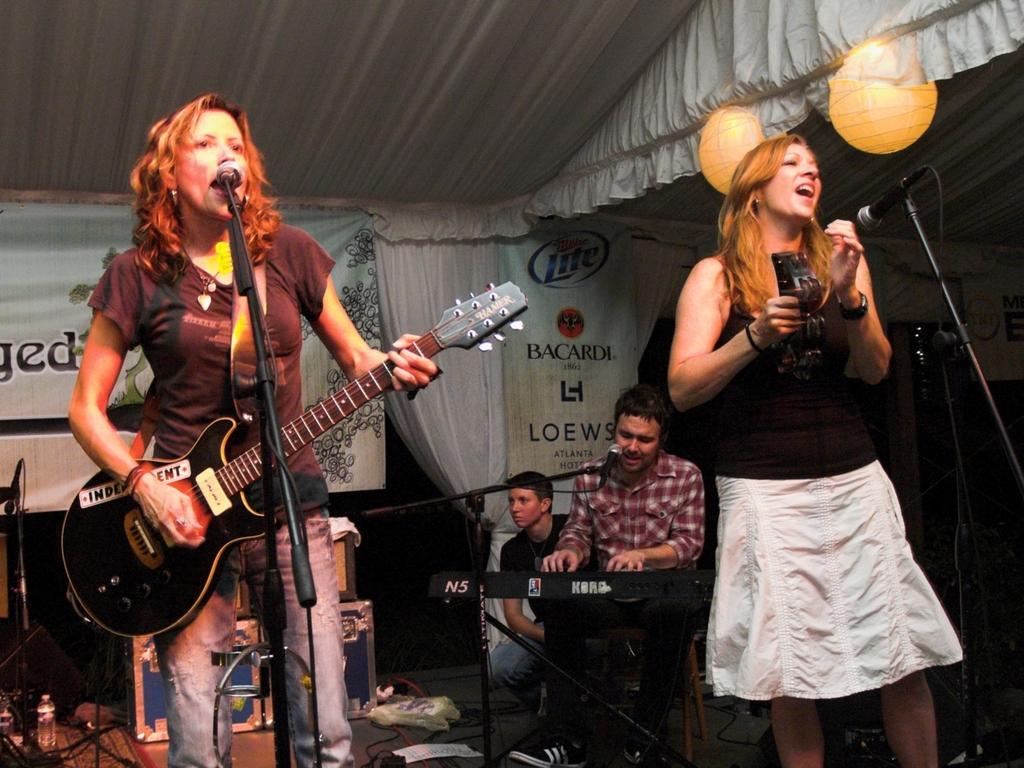Please provide a concise description of this image. These 2 women are playing musical instrument and singing in-front of mic. This man is sitting and playing a piano and singing in-front of mic. A banner on curtain. These are boxes. 